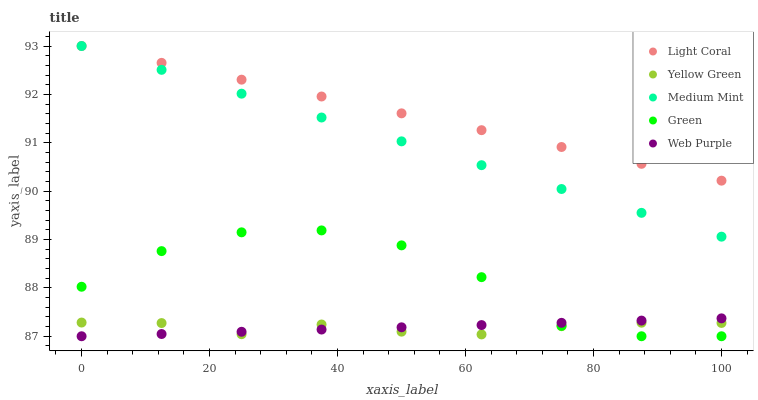Does Yellow Green have the minimum area under the curve?
Answer yes or no. Yes. Does Light Coral have the maximum area under the curve?
Answer yes or no. Yes. Does Medium Mint have the minimum area under the curve?
Answer yes or no. No. Does Medium Mint have the maximum area under the curve?
Answer yes or no. No. Is Light Coral the smoothest?
Answer yes or no. Yes. Is Green the roughest?
Answer yes or no. Yes. Is Medium Mint the smoothest?
Answer yes or no. No. Is Medium Mint the roughest?
Answer yes or no. No. Does Web Purple have the lowest value?
Answer yes or no. Yes. Does Medium Mint have the lowest value?
Answer yes or no. No. Does Medium Mint have the highest value?
Answer yes or no. Yes. Does Web Purple have the highest value?
Answer yes or no. No. Is Green less than Light Coral?
Answer yes or no. Yes. Is Light Coral greater than Web Purple?
Answer yes or no. Yes. Does Light Coral intersect Medium Mint?
Answer yes or no. Yes. Is Light Coral less than Medium Mint?
Answer yes or no. No. Is Light Coral greater than Medium Mint?
Answer yes or no. No. Does Green intersect Light Coral?
Answer yes or no. No. 